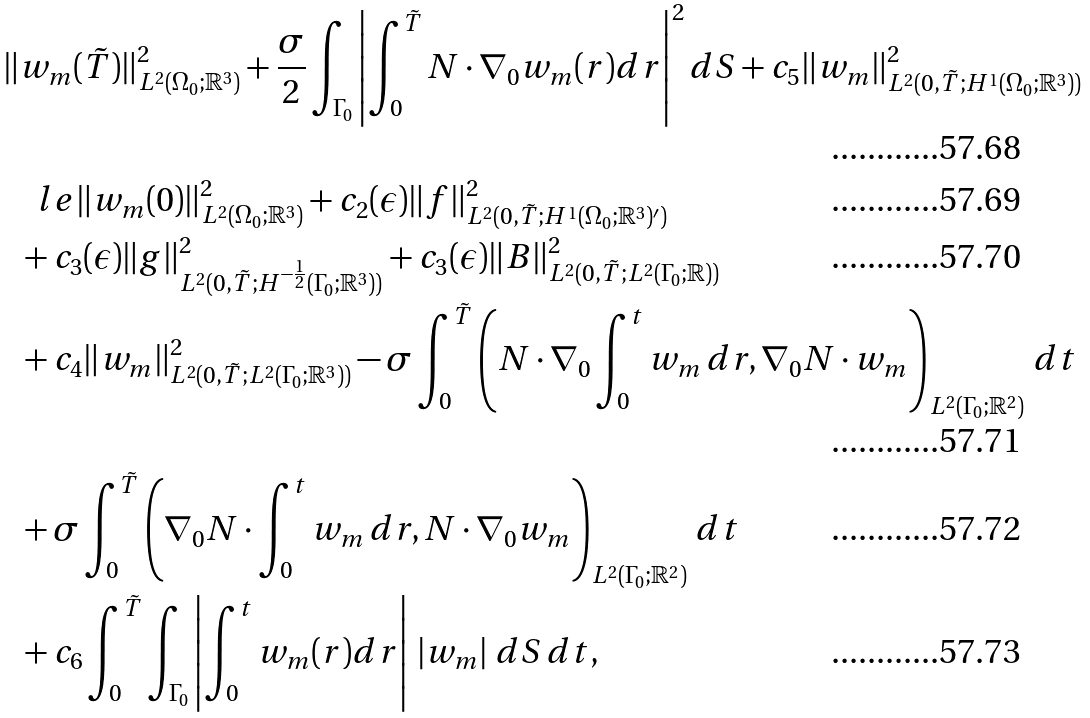<formula> <loc_0><loc_0><loc_500><loc_500>& \| w _ { m } ( \tilde { T } ) \| _ { L ^ { 2 } ( \Omega _ { 0 } ; { \mathbb { R } } ^ { 3 } ) } ^ { 2 } + \frac { \sigma } { 2 } \int _ { \Gamma _ { 0 } } \left | \int _ { 0 } ^ { \tilde { T } } N \cdot \nabla _ { 0 } w _ { m } ( r ) d r \right | ^ { 2 } d S + c _ { 5 } \| w _ { m } \| ^ { 2 } _ { L ^ { 2 } ( 0 , \tilde { T } ; H ^ { 1 } ( \Omega _ { 0 } ; { \mathbb { R } } ^ { 3 } ) ) } \\ & \quad l e \| w _ { m } ( 0 ) \| _ { L ^ { 2 } ( \Omega _ { 0 } ; { \mathbb { R } } ^ { 3 } ) } ^ { 2 } + c _ { 2 } ( \epsilon ) \| f \| ^ { 2 } _ { L ^ { 2 } ( 0 , \tilde { T } ; H ^ { 1 } ( \Omega _ { 0 } ; { \mathbb { R } } ^ { 3 } ) ^ { \prime } ) } \\ & \ \ + c _ { 3 } ( \epsilon ) \| g \| ^ { 2 } _ { L ^ { 2 } ( 0 , \tilde { T } ; H ^ { - \frac { 1 } { 2 } } ( \Gamma _ { 0 } ; { \mathbb { R } } ^ { 3 } ) ) } + c _ { 3 } ( \epsilon ) \| B \| ^ { 2 } _ { L ^ { 2 } ( 0 , \tilde { T } ; L ^ { 2 } ( \Gamma _ { 0 } ; { \mathbb { R } } ) ) } \\ & \ \ + c _ { 4 } \| w _ { m } \| ^ { 2 } _ { L ^ { 2 } ( 0 , \tilde { T } ; L ^ { 2 } ( \Gamma _ { 0 } ; { \mathbb { R } } ^ { 3 } ) ) } - \sigma \int _ { 0 } ^ { \tilde { T } } \left ( N \cdot \nabla _ { 0 } \int _ { 0 } ^ { t } w _ { m } \, d r , \nabla _ { 0 } N \cdot w _ { m } \right ) _ { L ^ { 2 } ( \Gamma _ { 0 } ; { \mathbb { R } } ^ { 2 } ) } \, d t \\ & \ \ + \sigma \int _ { 0 } ^ { \tilde { T } } \left ( \nabla _ { 0 } N \cdot \int _ { 0 } ^ { t } w _ { m } \, d r , N \cdot \nabla _ { 0 } w _ { m } \right ) _ { L ^ { 2 } ( \Gamma _ { 0 } ; { \mathbb { R } } ^ { 2 } ) } \, d t \\ & \ \ + c _ { 6 } \int _ { 0 } ^ { \tilde { T } } \int _ { \Gamma _ { 0 } } \left | \int _ { 0 } ^ { t } w _ { m } ( r ) d r \right | \, \left | w _ { m } \right | \, d S \, d t ,</formula> 